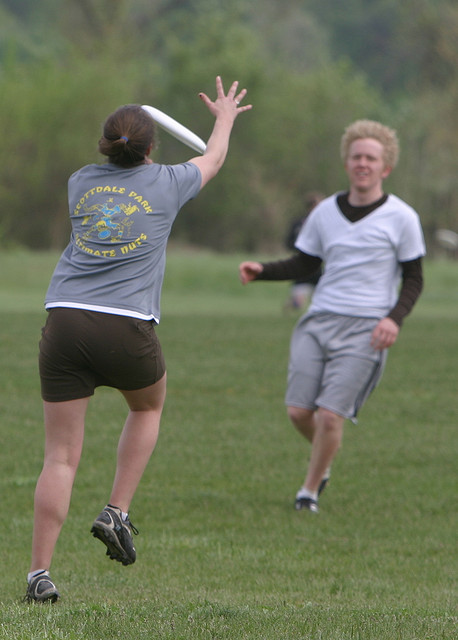<image>Are the player's laces wrapped under her cleats? I am not sure if the player's laces are wrapped under her cleats. It seems like they are not. Are the player's laces wrapped under her cleats? I don't know whether the player's laces are wrapped under her cleats. It is not clear from the given information. 